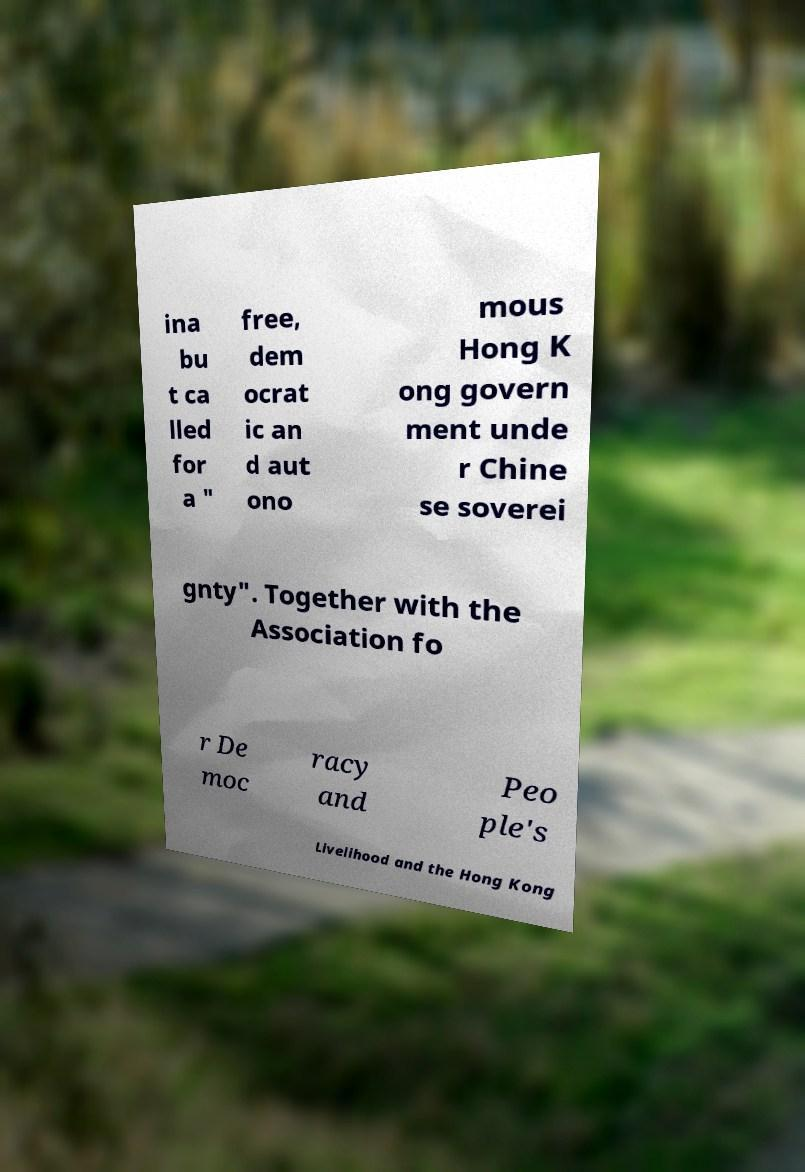Can you read and provide the text displayed in the image?This photo seems to have some interesting text. Can you extract and type it out for me? ina bu t ca lled for a " free, dem ocrat ic an d aut ono mous Hong K ong govern ment unde r Chine se soverei gnty". Together with the Association fo r De moc racy and Peo ple's Livelihood and the Hong Kong 